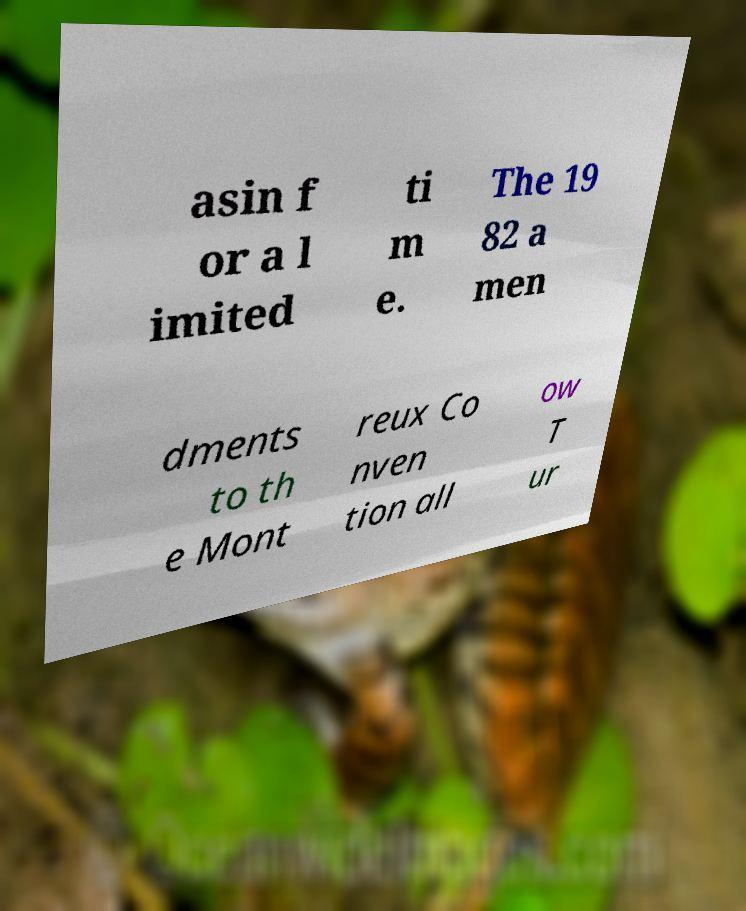Can you accurately transcribe the text from the provided image for me? asin f or a l imited ti m e. The 19 82 a men dments to th e Mont reux Co nven tion all ow T ur 